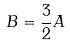<formula> <loc_0><loc_0><loc_500><loc_500>B = \frac { 3 } { 2 } A</formula> 